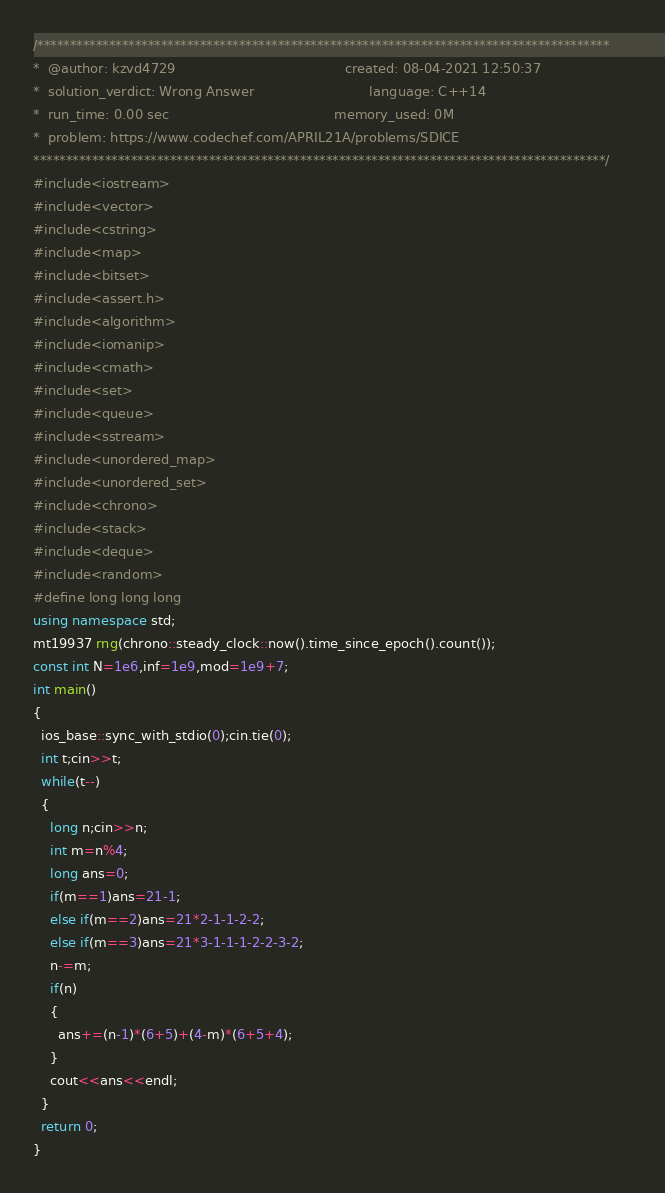<code> <loc_0><loc_0><loc_500><loc_500><_C++_>/****************************************************************************************
*  @author: kzvd4729                                         created: 08-04-2021 12:50:37                      
*  solution_verdict: Wrong Answer                            language: C++14                                   
*  run_time: 0.00 sec                                        memory_used: 0M                                   
*  problem: https://www.codechef.com/APRIL21A/problems/SDICE
****************************************************************************************/
#include<iostream>
#include<vector>
#include<cstring>
#include<map>
#include<bitset>
#include<assert.h>
#include<algorithm>
#include<iomanip>
#include<cmath>
#include<set>
#include<queue>
#include<sstream>
#include<unordered_map>
#include<unordered_set>
#include<chrono>
#include<stack>
#include<deque>
#include<random>
#define long long long
using namespace std;
mt19937 rng(chrono::steady_clock::now().time_since_epoch().count());
const int N=1e6,inf=1e9,mod=1e9+7;
int main()
{
  ios_base::sync_with_stdio(0);cin.tie(0);
  int t;cin>>t;
  while(t--)
  {
    long n;cin>>n;
    int m=n%4;
    long ans=0;
    if(m==1)ans=21-1;
    else if(m==2)ans=21*2-1-1-2-2;
    else if(m==3)ans=21*3-1-1-1-2-2-3-2;
    n-=m;
    if(n)
    {
      ans+=(n-1)*(6+5)+(4-m)*(6+5+4);
    }
    cout<<ans<<endl;
  }
  return 0;
}</code> 